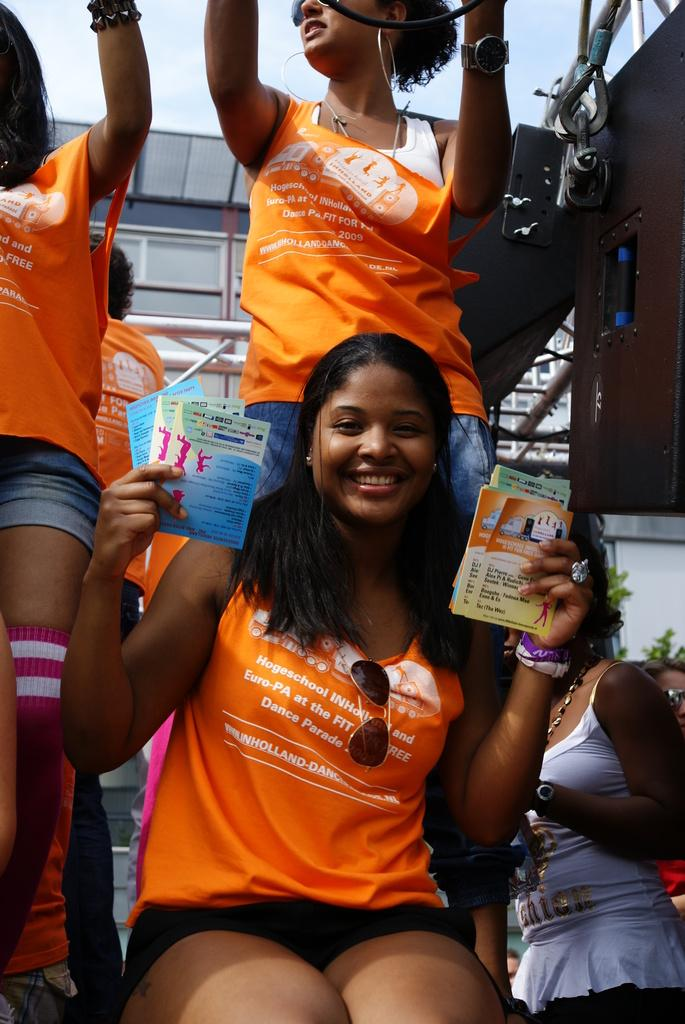How many people are in the image? There are persons standing in the image. What is one person doing in the image? One person is sitting on a wall in the image. What is the person sitting on the wall holding? The person sitting on the wall is holding papers. What can be seen in the background of the image? There are grills and the sky visible in the background of the image. Where is the nest of the bird in the image? There is no bird or nest present in the image. What type of substance is being polished by the person in the image? There is no person polishing any substance in the image. 